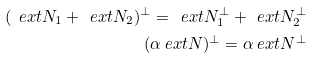<formula> <loc_0><loc_0><loc_500><loc_500>( \ e x t { N } _ { 1 } + \ e x t { N } _ { 2 } ) ^ { \perp } = \ e x t { N } _ { 1 } ^ { \perp } + \ e x t { N } _ { 2 } ^ { \perp } \\ ( \alpha \ e x t { N } ) ^ { \perp } = \alpha \ e x t { N } ^ { \perp }</formula> 